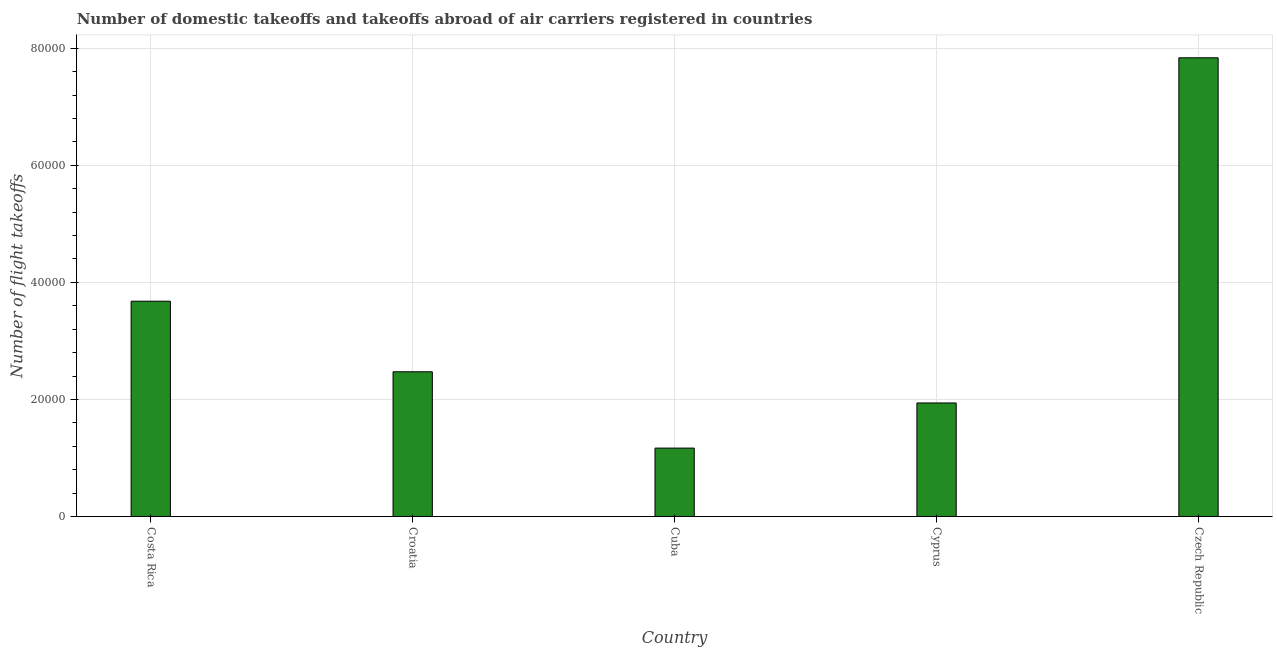Does the graph contain grids?
Ensure brevity in your answer.  Yes. What is the title of the graph?
Your response must be concise. Number of domestic takeoffs and takeoffs abroad of air carriers registered in countries. What is the label or title of the X-axis?
Provide a succinct answer. Country. What is the label or title of the Y-axis?
Your answer should be very brief. Number of flight takeoffs. What is the number of flight takeoffs in Cuba?
Ensure brevity in your answer.  1.17e+04. Across all countries, what is the maximum number of flight takeoffs?
Give a very brief answer. 7.84e+04. Across all countries, what is the minimum number of flight takeoffs?
Provide a succinct answer. 1.17e+04. In which country was the number of flight takeoffs maximum?
Provide a succinct answer. Czech Republic. In which country was the number of flight takeoffs minimum?
Your answer should be very brief. Cuba. What is the sum of the number of flight takeoffs?
Your response must be concise. 1.71e+05. What is the difference between the number of flight takeoffs in Costa Rica and Cuba?
Offer a terse response. 2.51e+04. What is the average number of flight takeoffs per country?
Your answer should be compact. 3.42e+04. What is the median number of flight takeoffs?
Make the answer very short. 2.47e+04. In how many countries, is the number of flight takeoffs greater than 48000 ?
Provide a short and direct response. 1. What is the ratio of the number of flight takeoffs in Croatia to that in Cyprus?
Provide a short and direct response. 1.27. Is the number of flight takeoffs in Costa Rica less than that in Cuba?
Make the answer very short. No. Is the difference between the number of flight takeoffs in Croatia and Cyprus greater than the difference between any two countries?
Your answer should be compact. No. What is the difference between the highest and the second highest number of flight takeoffs?
Ensure brevity in your answer.  4.16e+04. What is the difference between the highest and the lowest number of flight takeoffs?
Keep it short and to the point. 6.67e+04. In how many countries, is the number of flight takeoffs greater than the average number of flight takeoffs taken over all countries?
Provide a succinct answer. 2. How many bars are there?
Your answer should be very brief. 5. What is the difference between two consecutive major ticks on the Y-axis?
Your answer should be very brief. 2.00e+04. Are the values on the major ticks of Y-axis written in scientific E-notation?
Your answer should be compact. No. What is the Number of flight takeoffs of Costa Rica?
Provide a succinct answer. 3.68e+04. What is the Number of flight takeoffs of Croatia?
Make the answer very short. 2.47e+04. What is the Number of flight takeoffs of Cuba?
Ensure brevity in your answer.  1.17e+04. What is the Number of flight takeoffs of Cyprus?
Give a very brief answer. 1.94e+04. What is the Number of flight takeoffs of Czech Republic?
Provide a succinct answer. 7.84e+04. What is the difference between the Number of flight takeoffs in Costa Rica and Croatia?
Ensure brevity in your answer.  1.21e+04. What is the difference between the Number of flight takeoffs in Costa Rica and Cuba?
Ensure brevity in your answer.  2.51e+04. What is the difference between the Number of flight takeoffs in Costa Rica and Cyprus?
Make the answer very short. 1.74e+04. What is the difference between the Number of flight takeoffs in Costa Rica and Czech Republic?
Ensure brevity in your answer.  -4.16e+04. What is the difference between the Number of flight takeoffs in Croatia and Cuba?
Provide a short and direct response. 1.30e+04. What is the difference between the Number of flight takeoffs in Croatia and Cyprus?
Provide a succinct answer. 5329. What is the difference between the Number of flight takeoffs in Croatia and Czech Republic?
Your response must be concise. -5.36e+04. What is the difference between the Number of flight takeoffs in Cuba and Cyprus?
Your response must be concise. -7713. What is the difference between the Number of flight takeoffs in Cuba and Czech Republic?
Provide a short and direct response. -6.67e+04. What is the difference between the Number of flight takeoffs in Cyprus and Czech Republic?
Your answer should be compact. -5.90e+04. What is the ratio of the Number of flight takeoffs in Costa Rica to that in Croatia?
Provide a succinct answer. 1.49. What is the ratio of the Number of flight takeoffs in Costa Rica to that in Cuba?
Ensure brevity in your answer.  3.15. What is the ratio of the Number of flight takeoffs in Costa Rica to that in Cyprus?
Your response must be concise. 1.9. What is the ratio of the Number of flight takeoffs in Costa Rica to that in Czech Republic?
Your answer should be compact. 0.47. What is the ratio of the Number of flight takeoffs in Croatia to that in Cuba?
Keep it short and to the point. 2.12. What is the ratio of the Number of flight takeoffs in Croatia to that in Cyprus?
Your answer should be very brief. 1.27. What is the ratio of the Number of flight takeoffs in Croatia to that in Czech Republic?
Your answer should be compact. 0.32. What is the ratio of the Number of flight takeoffs in Cuba to that in Cyprus?
Your answer should be very brief. 0.6. What is the ratio of the Number of flight takeoffs in Cuba to that in Czech Republic?
Keep it short and to the point. 0.15. What is the ratio of the Number of flight takeoffs in Cyprus to that in Czech Republic?
Your answer should be very brief. 0.25. 